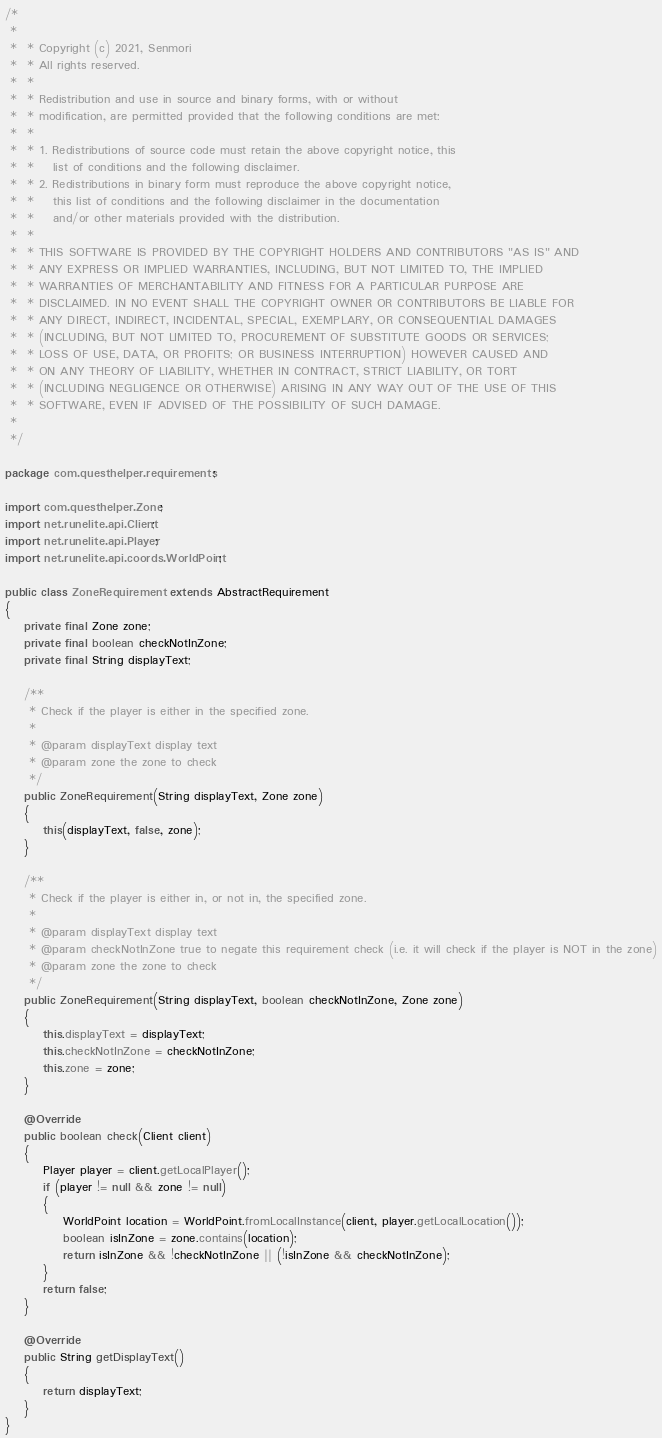<code> <loc_0><loc_0><loc_500><loc_500><_Java_>/*
 *
 *  * Copyright (c) 2021, Senmori
 *  * All rights reserved.
 *  *
 *  * Redistribution and use in source and binary forms, with or without
 *  * modification, are permitted provided that the following conditions are met:
 *  *
 *  * 1. Redistributions of source code must retain the above copyright notice, this
 *  *    list of conditions and the following disclaimer.
 *  * 2. Redistributions in binary form must reproduce the above copyright notice,
 *  *    this list of conditions and the following disclaimer in the documentation
 *  *    and/or other materials provided with the distribution.
 *  *
 *  * THIS SOFTWARE IS PROVIDED BY THE COPYRIGHT HOLDERS AND CONTRIBUTORS "AS IS" AND
 *  * ANY EXPRESS OR IMPLIED WARRANTIES, INCLUDING, BUT NOT LIMITED TO, THE IMPLIED
 *  * WARRANTIES OF MERCHANTABILITY AND FITNESS FOR A PARTICULAR PURPOSE ARE
 *  * DISCLAIMED. IN NO EVENT SHALL THE COPYRIGHT OWNER OR CONTRIBUTORS BE LIABLE FOR
 *  * ANY DIRECT, INDIRECT, INCIDENTAL, SPECIAL, EXEMPLARY, OR CONSEQUENTIAL DAMAGES
 *  * (INCLUDING, BUT NOT LIMITED TO, PROCUREMENT OF SUBSTITUTE GOODS OR SERVICES;
 *  * LOSS OF USE, DATA, OR PROFITS; OR BUSINESS INTERRUPTION) HOWEVER CAUSED AND
 *  * ON ANY THEORY OF LIABILITY, WHETHER IN CONTRACT, STRICT LIABILITY, OR TORT
 *  * (INCLUDING NEGLIGENCE OR OTHERWISE) ARISING IN ANY WAY OUT OF THE USE OF THIS
 *  * SOFTWARE, EVEN IF ADVISED OF THE POSSIBILITY OF SUCH DAMAGE.
 *
 */

package com.questhelper.requirements;

import com.questhelper.Zone;
import net.runelite.api.Client;
import net.runelite.api.Player;
import net.runelite.api.coords.WorldPoint;

public class ZoneRequirement extends AbstractRequirement
{
	private final Zone zone;
	private final boolean checkNotInZone;
	private final String displayText;

	/**
	 * Check if the player is either in the specified zone.
	 *
	 * @param displayText display text
	 * @param zone the zone to check
	 */
	public ZoneRequirement(String displayText, Zone zone)
	{
		this(displayText, false, zone);
	}

	/**
	 * Check if the player is either in, or not in, the specified zone.
	 *
	 * @param displayText display text
	 * @param checkNotInZone true to negate this requirement check (i.e. it will check if the player is NOT in the zone)
	 * @param zone the zone to check
	 */
	public ZoneRequirement(String displayText, boolean checkNotInZone, Zone zone)
	{
		this.displayText = displayText;
		this.checkNotInZone = checkNotInZone;
		this.zone = zone;
	}

	@Override
	public boolean check(Client client)
	{
		Player player = client.getLocalPlayer();
		if (player != null && zone != null)
		{
			WorldPoint location = WorldPoint.fromLocalInstance(client, player.getLocalLocation());
			boolean isInZone = zone.contains(location);
			return isInZone && !checkNotInZone || (!isInZone && checkNotInZone);
		}
		return false;
	}

	@Override
	public String getDisplayText()
	{
		return displayText;
	}
}
</code> 